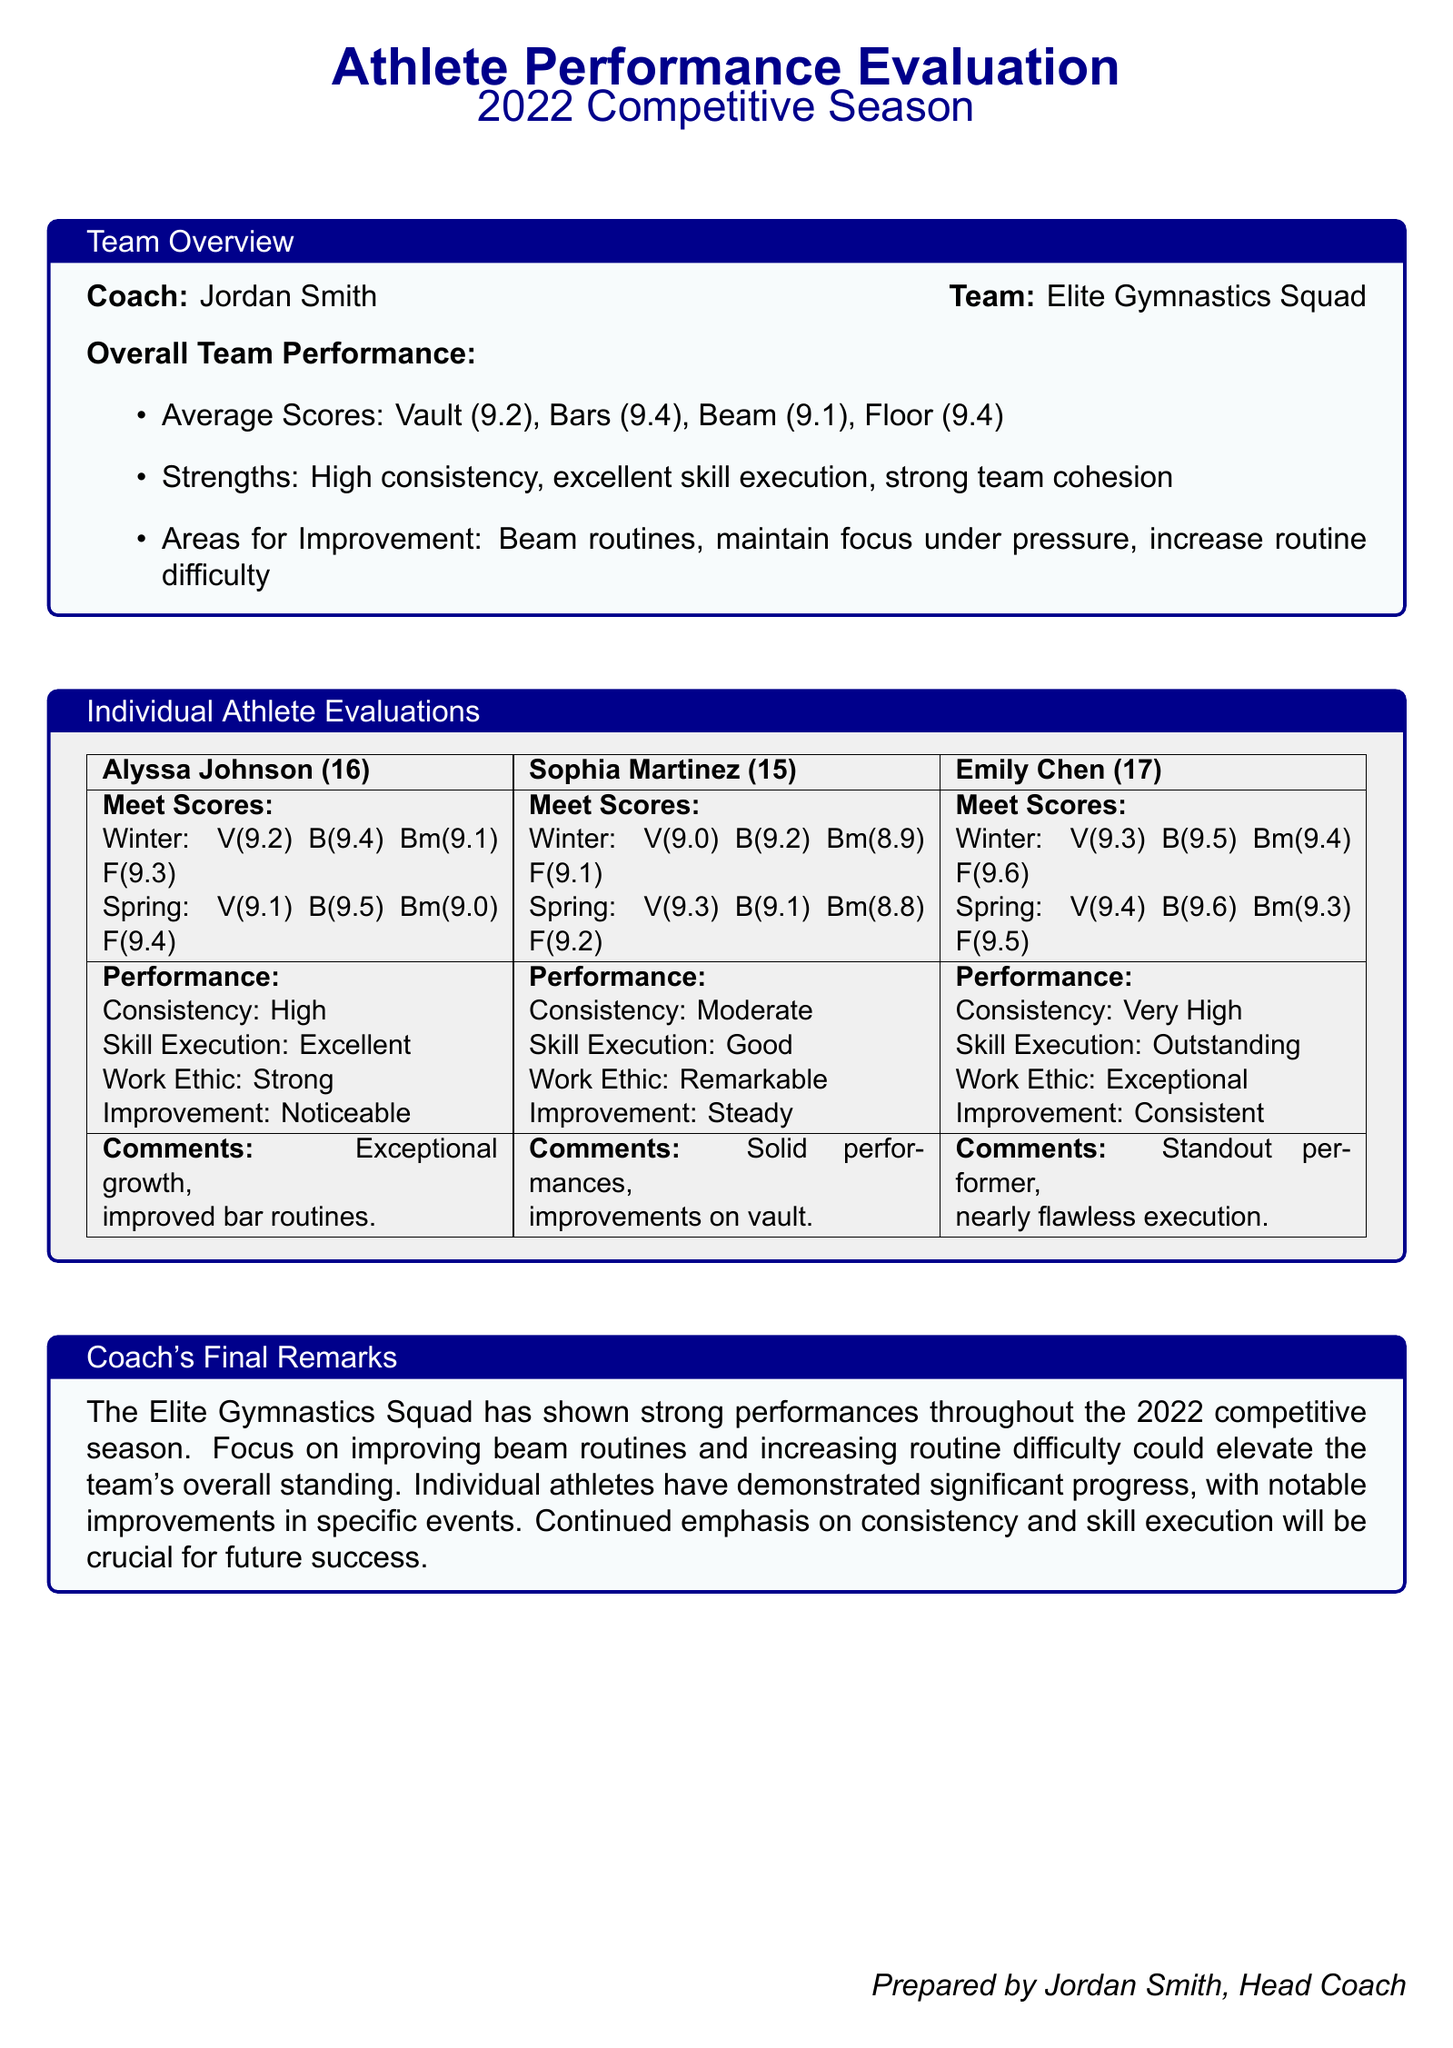What is the overall average score for the Vault? The overall average score for the Vault is mentioned in the team overview section, which explicitly states the average score.
Answer: 9.2 Who is the head coach of the team? The head coach's name is mentioned at the bottom of the document.
Answer: Jordan Smith What is the performance score for Emily Chen on Floor in Spring? The performance score for Emily Chen in Spring on Floor is detailed in her meet scores in the evaluation section.
Answer: 9.5 What is one area for improvement mentioned for the team? The areas for improvement are listed in the team overview section, outlining specific aspects that need focus.
Answer: Beam routines How does Alyssa Johnson's skill execution rank? The skill execution for Alyssa Johnson is categorized in her performance evaluation, indicating her level of skill.
Answer: Excellent What was Sophia Martinez's highest score on Beam? Sophia Martinez's highest score on Beam is obtained from the meet scores section directly.
Answer: 9.2 How did the team perform overall in the 2022 competitive season? The overall performance provides insight into the team's achievements and challenges during the season.
Answer: Strong performances What does the coach recommend for future success? The coach's recommendations are based on observations of the season and are stated in the final remarks section.
Answer: Emphasis on consistency and skill execution 